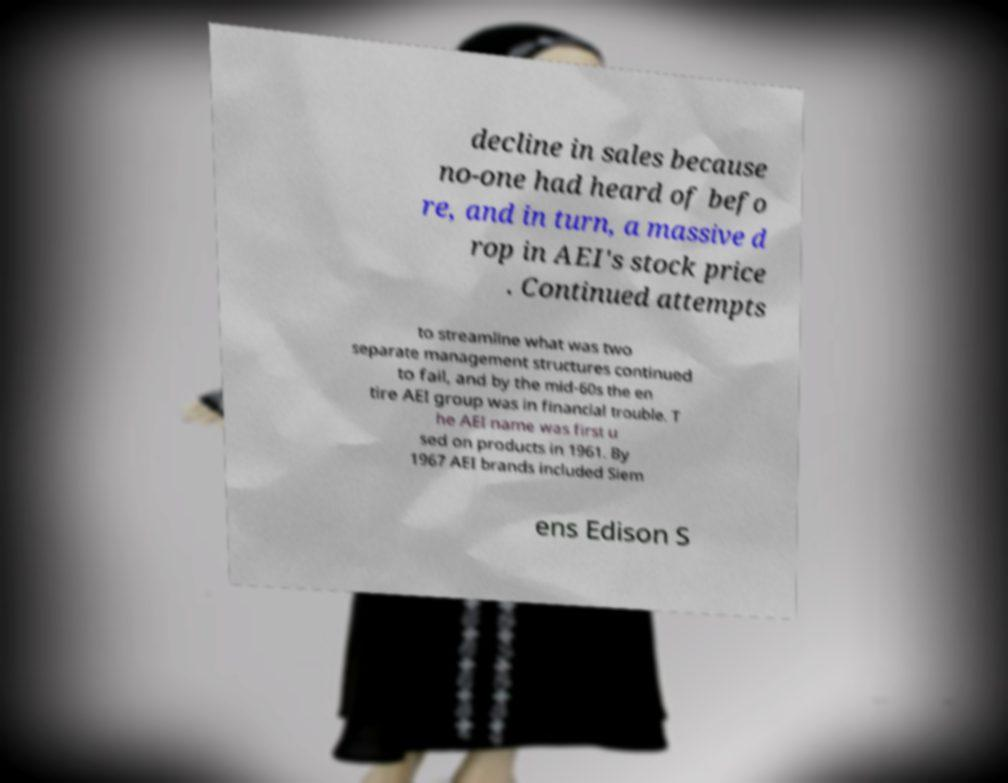There's text embedded in this image that I need extracted. Can you transcribe it verbatim? decline in sales because no-one had heard of befo re, and in turn, a massive d rop in AEI's stock price . Continued attempts to streamline what was two separate management structures continued to fail, and by the mid-60s the en tire AEI group was in financial trouble. T he AEI name was first u sed on products in 1961. By 1967 AEI brands included Siem ens Edison S 